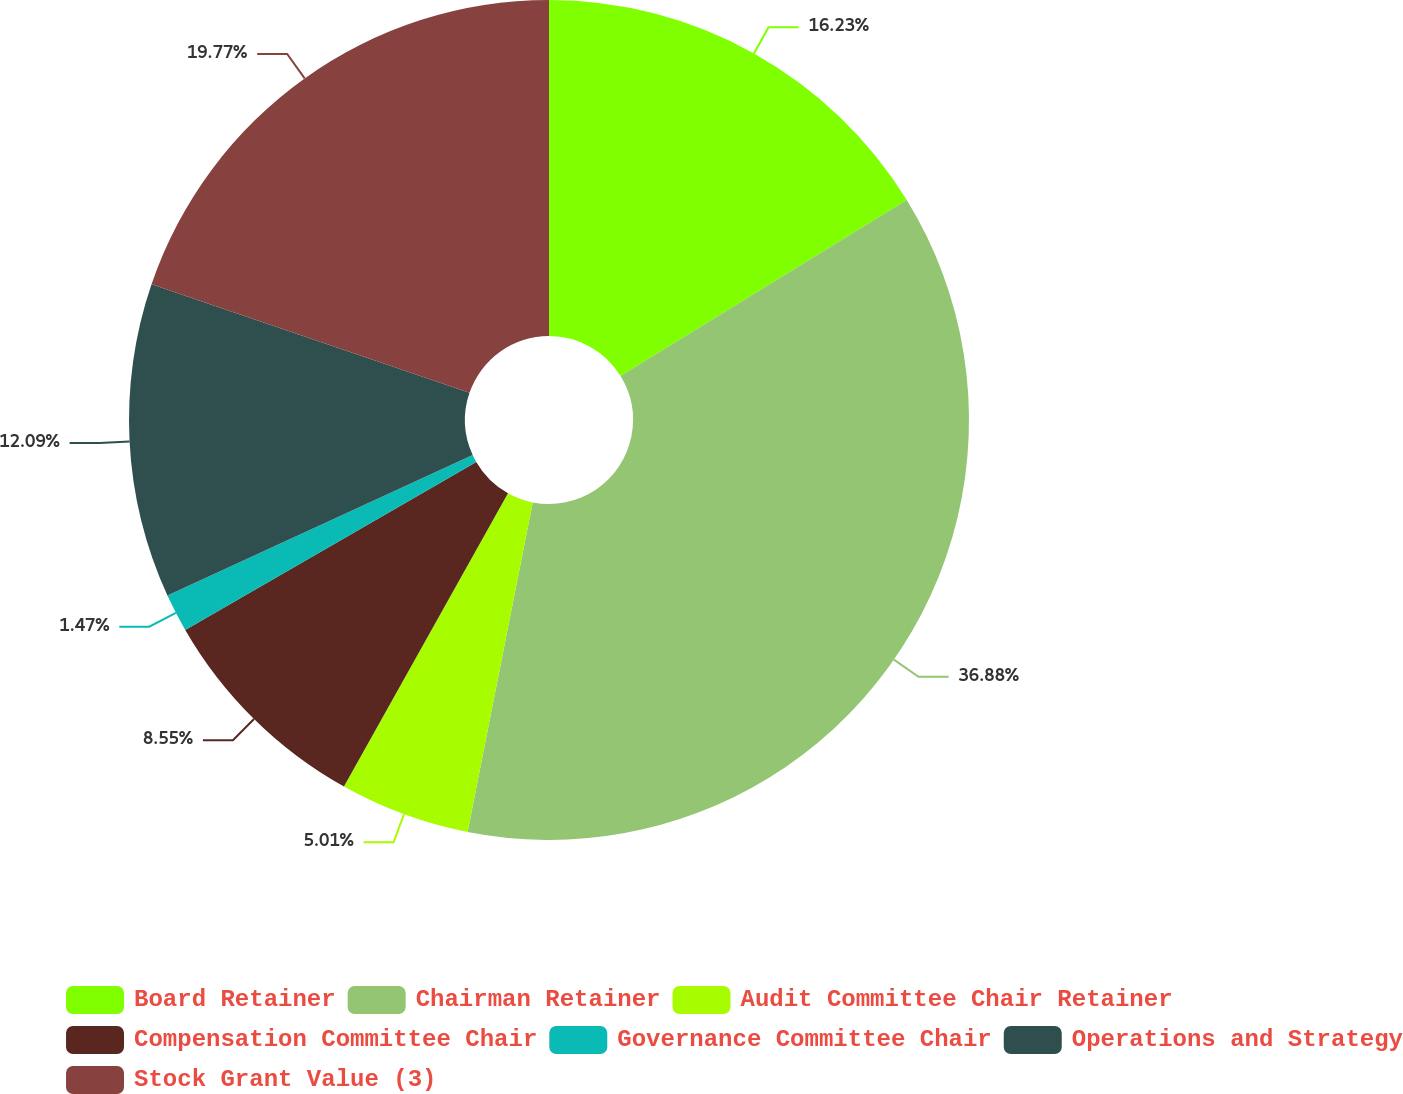Convert chart to OTSL. <chart><loc_0><loc_0><loc_500><loc_500><pie_chart><fcel>Board Retainer<fcel>Chairman Retainer<fcel>Audit Committee Chair Retainer<fcel>Compensation Committee Chair<fcel>Governance Committee Chair<fcel>Operations and Strategy<fcel>Stock Grant Value (3)<nl><fcel>16.22%<fcel>36.87%<fcel>5.01%<fcel>8.55%<fcel>1.47%<fcel>12.09%<fcel>19.76%<nl></chart> 